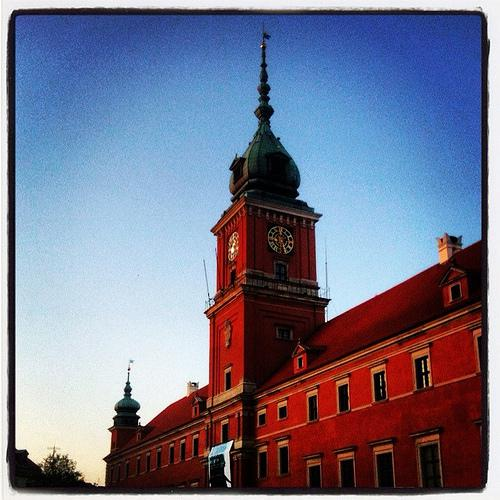Question: what color is the building?
Choices:
A. Blue.
B. Red.
C. Green.
D. Black.
Answer with the letter. Answer: B Question: what is this a picture of?
Choices:
A. Car.
B. Tree.
C. Building.
D. Dog.
Answer with the letter. Answer: C Question: where are the clocks?
Choices:
A. Bedroom.
B. Office.
C. Tower.
D. Train station.
Answer with the letter. Answer: C Question: how many clocks are visible?
Choices:
A. Three.
B. Two.
C. One.
D. Zero.
Answer with the letter. Answer: B 